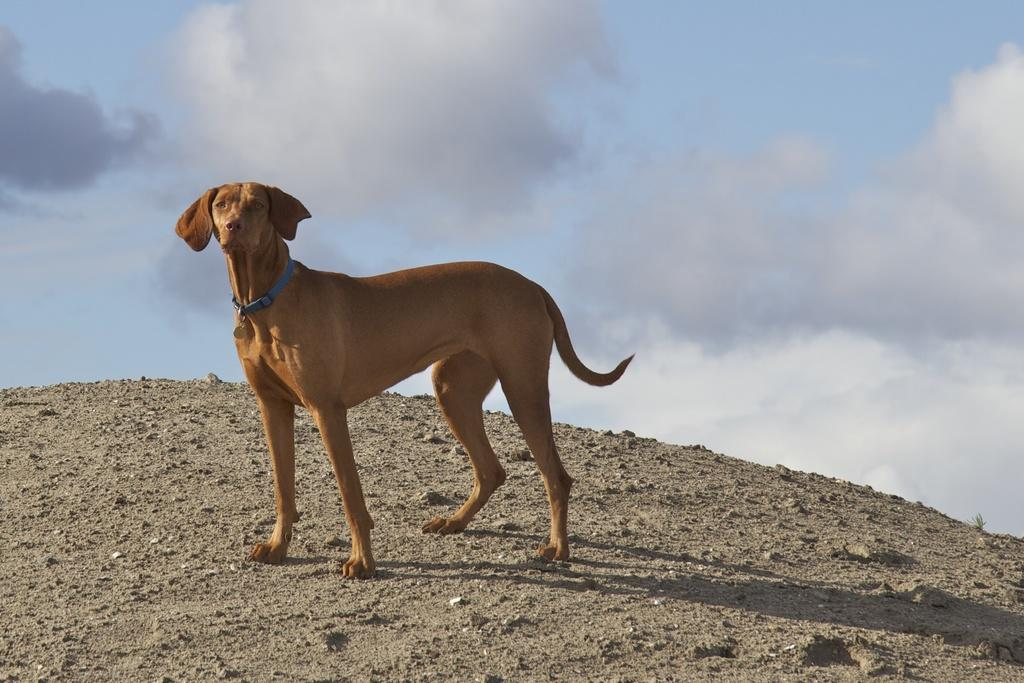What is the main subject in the foreground of the picture? There is a dog in the foreground of the picture. What is the dog doing in the picture? The dog is standing on the ground. What can be seen in the background of the picture? The sky is visible in the background of the picture. What is the condition of the sky in the picture? There are clouds in the sky. What type of plant is the dog using as a toy in the image? There is no plant present in the image, and the dog is not using any object as a toy. 